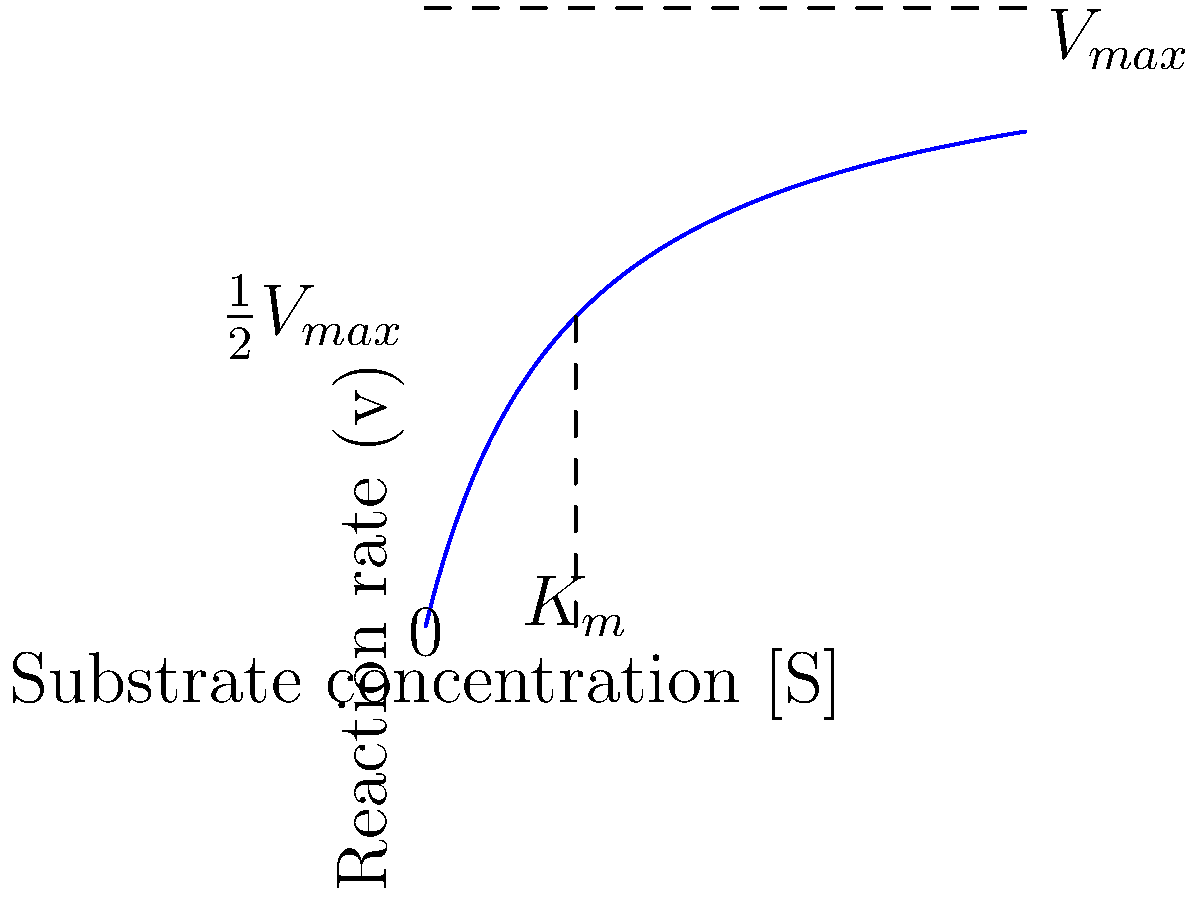Examine the enzyme kinetics graph above, which shows the relationship between substrate concentration [S] and reaction rate (v) for a typical enzyme-catalyzed reaction. What is the significance of the point where the substrate concentration equals $K_m$, and how does it relate to $V_{max}$? To answer this question, let's analyze the graph step-by-step:

1. The graph shows a typical Michaelis-Menten kinetics curve for an enzyme-catalyzed reaction.

2. $V_{max}$ represents the maximum reaction rate, which is approached asymptotically as substrate concentration increases.

3. $K_m$ is the Michaelis constant, which is the substrate concentration at which the reaction rate is half of $V_{max}$.

4. On the graph, we can see that when [S] = $K_m$:
   a) The reaction rate (v) is exactly half of $V_{max}$.
   b) This point occurs at the substrate concentration where the curve begins to level off.

5. The significance of $K_m$ is that it:
   a) Indicates the enzyme's affinity for the substrate (lower $K_m$ means higher affinity).
   b) Represents the substrate concentration at which the enzyme is operating at half its maximum efficiency.

6. The relationship between $K_m$ and $V_{max}$ can be expressed mathematically in the Michaelis-Menten equation:

   $$ v = \frac{V_{max}[S]}{K_m + [S]} $$

7. When [S] = $K_m$, this equation simplifies to:

   $$ v = \frac{V_{max}K_m}{K_m + K_m} = \frac{V_{max}K_m}{2K_m} = \frac{1}{2}V_{max} $$

This demonstrates that at [S] = $K_m$, the reaction rate is indeed half of $V_{max}$.
Answer: At [S] = $K_m$, the reaction rate is $\frac{1}{2}V_{max}$, indicating enzyme half-saturation and substrate affinity. 